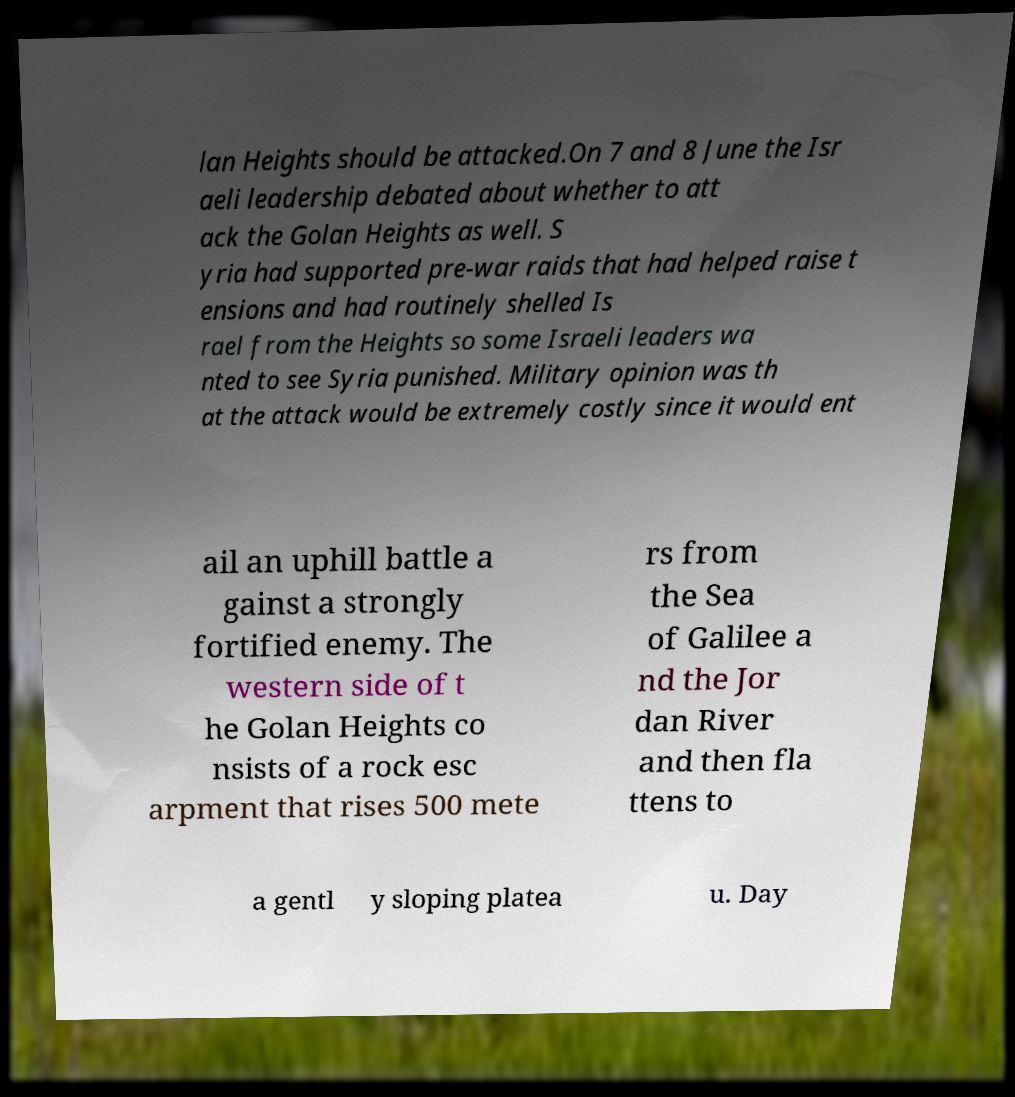I need the written content from this picture converted into text. Can you do that? lan Heights should be attacked.On 7 and 8 June the Isr aeli leadership debated about whether to att ack the Golan Heights as well. S yria had supported pre-war raids that had helped raise t ensions and had routinely shelled Is rael from the Heights so some Israeli leaders wa nted to see Syria punished. Military opinion was th at the attack would be extremely costly since it would ent ail an uphill battle a gainst a strongly fortified enemy. The western side of t he Golan Heights co nsists of a rock esc arpment that rises 500 mete rs from the Sea of Galilee a nd the Jor dan River and then fla ttens to a gentl y sloping platea u. Day 